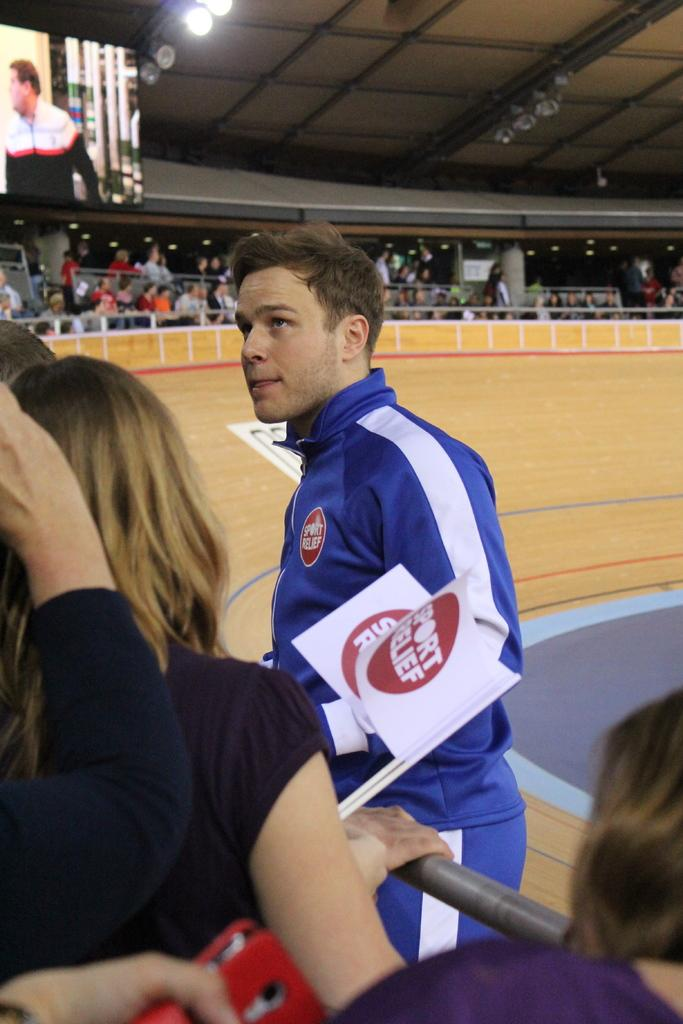What are the people in the image wearing? The persons in the image are wearing clothes. What can be seen in the middle of the image? There is a crowd in the middle of the image. What is located in the top left of the image? There is a screen and lights in the top left of the image. Can you tell me how many goldfish are swimming in the bedroom in the image? There is no bedroom or goldfish present in the image. Who is the friend standing next to the person in the image? There is no friend or person standing next to anyone in the image. 